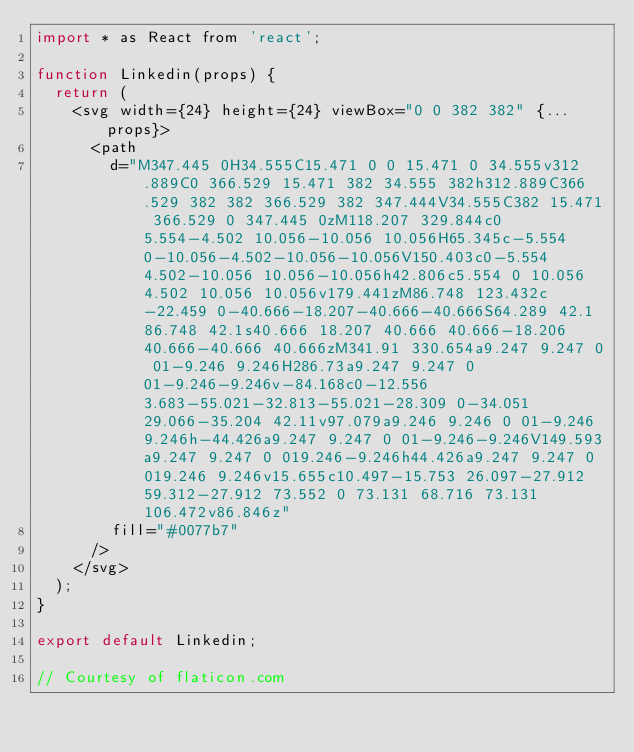Convert code to text. <code><loc_0><loc_0><loc_500><loc_500><_JavaScript_>import * as React from 'react';

function Linkedin(props) {
  return (
    <svg width={24} height={24} viewBox="0 0 382 382" {...props}>
      <path
        d="M347.445 0H34.555C15.471 0 0 15.471 0 34.555v312.889C0 366.529 15.471 382 34.555 382h312.889C366.529 382 382 366.529 382 347.444V34.555C382 15.471 366.529 0 347.445 0zM118.207 329.844c0 5.554-4.502 10.056-10.056 10.056H65.345c-5.554 0-10.056-4.502-10.056-10.056V150.403c0-5.554 4.502-10.056 10.056-10.056h42.806c5.554 0 10.056 4.502 10.056 10.056v179.441zM86.748 123.432c-22.459 0-40.666-18.207-40.666-40.666S64.289 42.1 86.748 42.1s40.666 18.207 40.666 40.666-18.206 40.666-40.666 40.666zM341.91 330.654a9.247 9.247 0 01-9.246 9.246H286.73a9.247 9.247 0 01-9.246-9.246v-84.168c0-12.556 3.683-55.021-32.813-55.021-28.309 0-34.051 29.066-35.204 42.11v97.079a9.246 9.246 0 01-9.246 9.246h-44.426a9.247 9.247 0 01-9.246-9.246V149.593a9.247 9.247 0 019.246-9.246h44.426a9.247 9.247 0 019.246 9.246v15.655c10.497-15.753 26.097-27.912 59.312-27.912 73.552 0 73.131 68.716 73.131 106.472v86.846z"
        fill="#0077b7"
      />
    </svg>
  );
}

export default Linkedin;

// Courtesy of flaticon.com
</code> 